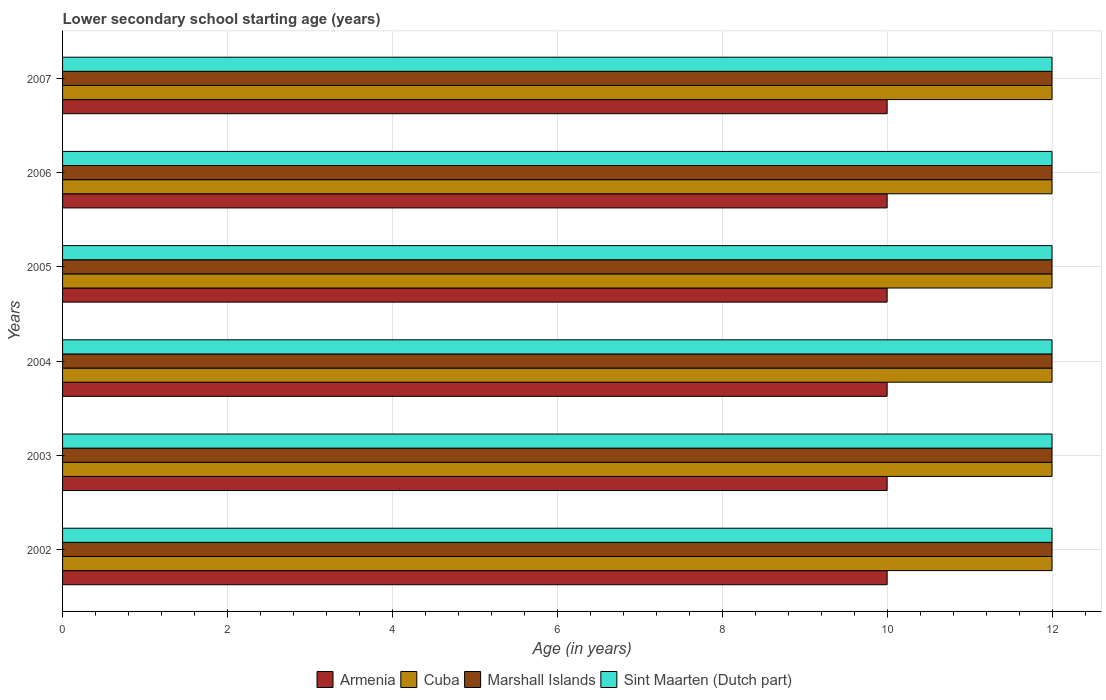How many groups of bars are there?
Give a very brief answer. 6. Are the number of bars on each tick of the Y-axis equal?
Provide a short and direct response. Yes. How many bars are there on the 2nd tick from the bottom?
Offer a very short reply. 4. What is the lower secondary school starting age of children in Armenia in 2002?
Make the answer very short. 10. Across all years, what is the minimum lower secondary school starting age of children in Cuba?
Keep it short and to the point. 12. What is the total lower secondary school starting age of children in Cuba in the graph?
Offer a very short reply. 72. What is the average lower secondary school starting age of children in Sint Maarten (Dutch part) per year?
Provide a succinct answer. 12. In how many years, is the lower secondary school starting age of children in Armenia greater than 4.8 years?
Your answer should be compact. 6. What is the ratio of the lower secondary school starting age of children in Cuba in 2006 to that in 2007?
Ensure brevity in your answer.  1. Is the difference between the lower secondary school starting age of children in Sint Maarten (Dutch part) in 2002 and 2006 greater than the difference between the lower secondary school starting age of children in Armenia in 2002 and 2006?
Provide a short and direct response. No. Is the sum of the lower secondary school starting age of children in Sint Maarten (Dutch part) in 2002 and 2003 greater than the maximum lower secondary school starting age of children in Marshall Islands across all years?
Keep it short and to the point. Yes. What does the 1st bar from the top in 2004 represents?
Provide a succinct answer. Sint Maarten (Dutch part). What does the 2nd bar from the bottom in 2003 represents?
Your answer should be compact. Cuba. Is it the case that in every year, the sum of the lower secondary school starting age of children in Marshall Islands and lower secondary school starting age of children in Armenia is greater than the lower secondary school starting age of children in Cuba?
Ensure brevity in your answer.  Yes. How many bars are there?
Provide a succinct answer. 24. Are all the bars in the graph horizontal?
Your response must be concise. Yes. What is the difference between two consecutive major ticks on the X-axis?
Your answer should be compact. 2. Are the values on the major ticks of X-axis written in scientific E-notation?
Your response must be concise. No. How many legend labels are there?
Offer a very short reply. 4. How are the legend labels stacked?
Keep it short and to the point. Horizontal. What is the title of the graph?
Provide a short and direct response. Lower secondary school starting age (years). What is the label or title of the X-axis?
Offer a very short reply. Age (in years). What is the Age (in years) of Armenia in 2002?
Provide a short and direct response. 10. What is the Age (in years) in Armenia in 2003?
Your response must be concise. 10. What is the Age (in years) of Marshall Islands in 2003?
Provide a succinct answer. 12. What is the Age (in years) in Sint Maarten (Dutch part) in 2003?
Offer a very short reply. 12. What is the Age (in years) in Sint Maarten (Dutch part) in 2004?
Provide a succinct answer. 12. What is the Age (in years) of Armenia in 2005?
Ensure brevity in your answer.  10. What is the Age (in years) of Cuba in 2005?
Ensure brevity in your answer.  12. What is the Age (in years) in Marshall Islands in 2005?
Keep it short and to the point. 12. What is the Age (in years) in Cuba in 2006?
Your answer should be very brief. 12. What is the Age (in years) in Marshall Islands in 2006?
Provide a succinct answer. 12. What is the Age (in years) in Armenia in 2007?
Keep it short and to the point. 10. What is the Age (in years) of Cuba in 2007?
Make the answer very short. 12. What is the Age (in years) in Marshall Islands in 2007?
Make the answer very short. 12. Across all years, what is the maximum Age (in years) in Armenia?
Your answer should be very brief. 10. Across all years, what is the maximum Age (in years) in Cuba?
Provide a succinct answer. 12. Across all years, what is the minimum Age (in years) in Armenia?
Offer a terse response. 10. Across all years, what is the minimum Age (in years) of Marshall Islands?
Provide a succinct answer. 12. What is the total Age (in years) of Armenia in the graph?
Your response must be concise. 60. What is the total Age (in years) in Cuba in the graph?
Keep it short and to the point. 72. What is the difference between the Age (in years) of Armenia in 2002 and that in 2003?
Offer a terse response. 0. What is the difference between the Age (in years) of Cuba in 2002 and that in 2003?
Your answer should be very brief. 0. What is the difference between the Age (in years) in Marshall Islands in 2002 and that in 2003?
Make the answer very short. 0. What is the difference between the Age (in years) of Sint Maarten (Dutch part) in 2002 and that in 2003?
Offer a very short reply. 0. What is the difference between the Age (in years) of Armenia in 2002 and that in 2004?
Ensure brevity in your answer.  0. What is the difference between the Age (in years) in Cuba in 2002 and that in 2004?
Give a very brief answer. 0. What is the difference between the Age (in years) of Marshall Islands in 2002 and that in 2004?
Offer a terse response. 0. What is the difference between the Age (in years) of Sint Maarten (Dutch part) in 2002 and that in 2004?
Your answer should be very brief. 0. What is the difference between the Age (in years) of Armenia in 2002 and that in 2005?
Make the answer very short. 0. What is the difference between the Age (in years) of Cuba in 2002 and that in 2005?
Ensure brevity in your answer.  0. What is the difference between the Age (in years) in Sint Maarten (Dutch part) in 2002 and that in 2005?
Give a very brief answer. 0. What is the difference between the Age (in years) in Cuba in 2002 and that in 2006?
Make the answer very short. 0. What is the difference between the Age (in years) in Marshall Islands in 2002 and that in 2006?
Ensure brevity in your answer.  0. What is the difference between the Age (in years) in Sint Maarten (Dutch part) in 2002 and that in 2006?
Offer a terse response. 0. What is the difference between the Age (in years) in Armenia in 2002 and that in 2007?
Provide a short and direct response. 0. What is the difference between the Age (in years) of Cuba in 2002 and that in 2007?
Your answer should be compact. 0. What is the difference between the Age (in years) in Marshall Islands in 2002 and that in 2007?
Your response must be concise. 0. What is the difference between the Age (in years) of Sint Maarten (Dutch part) in 2002 and that in 2007?
Give a very brief answer. 0. What is the difference between the Age (in years) of Armenia in 2003 and that in 2004?
Your response must be concise. 0. What is the difference between the Age (in years) of Armenia in 2003 and that in 2005?
Ensure brevity in your answer.  0. What is the difference between the Age (in years) of Sint Maarten (Dutch part) in 2003 and that in 2005?
Give a very brief answer. 0. What is the difference between the Age (in years) in Armenia in 2003 and that in 2006?
Make the answer very short. 0. What is the difference between the Age (in years) in Marshall Islands in 2003 and that in 2007?
Your answer should be compact. 0. What is the difference between the Age (in years) of Marshall Islands in 2004 and that in 2005?
Give a very brief answer. 0. What is the difference between the Age (in years) of Armenia in 2004 and that in 2007?
Offer a terse response. 0. What is the difference between the Age (in years) of Marshall Islands in 2004 and that in 2007?
Your response must be concise. 0. What is the difference between the Age (in years) of Sint Maarten (Dutch part) in 2004 and that in 2007?
Your answer should be compact. 0. What is the difference between the Age (in years) of Cuba in 2005 and that in 2006?
Offer a very short reply. 0. What is the difference between the Age (in years) of Marshall Islands in 2005 and that in 2006?
Offer a terse response. 0. What is the difference between the Age (in years) in Cuba in 2005 and that in 2007?
Offer a terse response. 0. What is the difference between the Age (in years) in Armenia in 2006 and that in 2007?
Your answer should be compact. 0. What is the difference between the Age (in years) in Marshall Islands in 2006 and that in 2007?
Provide a short and direct response. 0. What is the difference between the Age (in years) in Cuba in 2002 and the Age (in years) in Sint Maarten (Dutch part) in 2004?
Give a very brief answer. 0. What is the difference between the Age (in years) of Armenia in 2002 and the Age (in years) of Marshall Islands in 2005?
Your response must be concise. -2. What is the difference between the Age (in years) of Armenia in 2002 and the Age (in years) of Sint Maarten (Dutch part) in 2005?
Give a very brief answer. -2. What is the difference between the Age (in years) of Cuba in 2002 and the Age (in years) of Sint Maarten (Dutch part) in 2005?
Your answer should be very brief. 0. What is the difference between the Age (in years) in Armenia in 2002 and the Age (in years) in Marshall Islands in 2006?
Keep it short and to the point. -2. What is the difference between the Age (in years) in Armenia in 2002 and the Age (in years) in Sint Maarten (Dutch part) in 2006?
Keep it short and to the point. -2. What is the difference between the Age (in years) in Cuba in 2002 and the Age (in years) in Marshall Islands in 2006?
Offer a terse response. 0. What is the difference between the Age (in years) in Cuba in 2002 and the Age (in years) in Sint Maarten (Dutch part) in 2006?
Keep it short and to the point. 0. What is the difference between the Age (in years) in Armenia in 2002 and the Age (in years) in Sint Maarten (Dutch part) in 2007?
Provide a succinct answer. -2. What is the difference between the Age (in years) of Cuba in 2002 and the Age (in years) of Sint Maarten (Dutch part) in 2007?
Provide a short and direct response. 0. What is the difference between the Age (in years) of Armenia in 2003 and the Age (in years) of Cuba in 2004?
Provide a short and direct response. -2. What is the difference between the Age (in years) in Cuba in 2003 and the Age (in years) in Marshall Islands in 2004?
Provide a short and direct response. 0. What is the difference between the Age (in years) in Cuba in 2003 and the Age (in years) in Sint Maarten (Dutch part) in 2004?
Your answer should be very brief. 0. What is the difference between the Age (in years) of Armenia in 2003 and the Age (in years) of Marshall Islands in 2005?
Offer a terse response. -2. What is the difference between the Age (in years) in Armenia in 2003 and the Age (in years) in Sint Maarten (Dutch part) in 2005?
Provide a short and direct response. -2. What is the difference between the Age (in years) of Cuba in 2003 and the Age (in years) of Sint Maarten (Dutch part) in 2005?
Ensure brevity in your answer.  0. What is the difference between the Age (in years) in Armenia in 2003 and the Age (in years) in Cuba in 2006?
Keep it short and to the point. -2. What is the difference between the Age (in years) of Armenia in 2003 and the Age (in years) of Marshall Islands in 2006?
Provide a short and direct response. -2. What is the difference between the Age (in years) of Armenia in 2003 and the Age (in years) of Sint Maarten (Dutch part) in 2006?
Your response must be concise. -2. What is the difference between the Age (in years) in Cuba in 2003 and the Age (in years) in Marshall Islands in 2007?
Your answer should be compact. 0. What is the difference between the Age (in years) in Marshall Islands in 2003 and the Age (in years) in Sint Maarten (Dutch part) in 2007?
Give a very brief answer. 0. What is the difference between the Age (in years) of Armenia in 2004 and the Age (in years) of Sint Maarten (Dutch part) in 2005?
Make the answer very short. -2. What is the difference between the Age (in years) in Cuba in 2004 and the Age (in years) in Marshall Islands in 2005?
Provide a succinct answer. 0. What is the difference between the Age (in years) of Cuba in 2004 and the Age (in years) of Marshall Islands in 2006?
Provide a short and direct response. 0. What is the difference between the Age (in years) in Armenia in 2004 and the Age (in years) in Marshall Islands in 2007?
Provide a short and direct response. -2. What is the difference between the Age (in years) of Armenia in 2004 and the Age (in years) of Sint Maarten (Dutch part) in 2007?
Make the answer very short. -2. What is the difference between the Age (in years) of Marshall Islands in 2004 and the Age (in years) of Sint Maarten (Dutch part) in 2007?
Your answer should be very brief. 0. What is the difference between the Age (in years) in Armenia in 2005 and the Age (in years) in Sint Maarten (Dutch part) in 2006?
Your answer should be compact. -2. What is the difference between the Age (in years) of Cuba in 2005 and the Age (in years) of Sint Maarten (Dutch part) in 2006?
Provide a succinct answer. 0. What is the difference between the Age (in years) of Marshall Islands in 2005 and the Age (in years) of Sint Maarten (Dutch part) in 2006?
Provide a succinct answer. 0. What is the difference between the Age (in years) in Armenia in 2005 and the Age (in years) in Cuba in 2007?
Give a very brief answer. -2. What is the difference between the Age (in years) of Armenia in 2005 and the Age (in years) of Marshall Islands in 2007?
Your response must be concise. -2. What is the difference between the Age (in years) in Armenia in 2005 and the Age (in years) in Sint Maarten (Dutch part) in 2007?
Provide a succinct answer. -2. What is the difference between the Age (in years) in Cuba in 2005 and the Age (in years) in Marshall Islands in 2007?
Provide a short and direct response. 0. What is the difference between the Age (in years) of Cuba in 2005 and the Age (in years) of Sint Maarten (Dutch part) in 2007?
Keep it short and to the point. 0. What is the difference between the Age (in years) in Marshall Islands in 2005 and the Age (in years) in Sint Maarten (Dutch part) in 2007?
Your answer should be compact. 0. What is the difference between the Age (in years) of Armenia in 2006 and the Age (in years) of Cuba in 2007?
Your response must be concise. -2. What is the difference between the Age (in years) of Armenia in 2006 and the Age (in years) of Marshall Islands in 2007?
Give a very brief answer. -2. What is the average Age (in years) of Cuba per year?
Your response must be concise. 12. What is the average Age (in years) of Sint Maarten (Dutch part) per year?
Offer a terse response. 12. In the year 2002, what is the difference between the Age (in years) of Marshall Islands and Age (in years) of Sint Maarten (Dutch part)?
Your response must be concise. 0. In the year 2003, what is the difference between the Age (in years) in Armenia and Age (in years) in Cuba?
Ensure brevity in your answer.  -2. In the year 2003, what is the difference between the Age (in years) of Armenia and Age (in years) of Marshall Islands?
Your answer should be very brief. -2. In the year 2003, what is the difference between the Age (in years) in Marshall Islands and Age (in years) in Sint Maarten (Dutch part)?
Keep it short and to the point. 0. In the year 2004, what is the difference between the Age (in years) in Armenia and Age (in years) in Cuba?
Your response must be concise. -2. In the year 2004, what is the difference between the Age (in years) in Armenia and Age (in years) in Marshall Islands?
Your response must be concise. -2. In the year 2004, what is the difference between the Age (in years) of Armenia and Age (in years) of Sint Maarten (Dutch part)?
Make the answer very short. -2. In the year 2004, what is the difference between the Age (in years) of Cuba and Age (in years) of Marshall Islands?
Ensure brevity in your answer.  0. In the year 2004, what is the difference between the Age (in years) in Cuba and Age (in years) in Sint Maarten (Dutch part)?
Your answer should be very brief. 0. In the year 2005, what is the difference between the Age (in years) in Armenia and Age (in years) in Cuba?
Offer a very short reply. -2. In the year 2005, what is the difference between the Age (in years) in Cuba and Age (in years) in Sint Maarten (Dutch part)?
Provide a succinct answer. 0. In the year 2005, what is the difference between the Age (in years) in Marshall Islands and Age (in years) in Sint Maarten (Dutch part)?
Provide a succinct answer. 0. In the year 2006, what is the difference between the Age (in years) in Armenia and Age (in years) in Cuba?
Ensure brevity in your answer.  -2. In the year 2006, what is the difference between the Age (in years) of Armenia and Age (in years) of Sint Maarten (Dutch part)?
Make the answer very short. -2. In the year 2006, what is the difference between the Age (in years) of Cuba and Age (in years) of Sint Maarten (Dutch part)?
Offer a very short reply. 0. In the year 2007, what is the difference between the Age (in years) of Armenia and Age (in years) of Marshall Islands?
Offer a terse response. -2. In the year 2007, what is the difference between the Age (in years) of Cuba and Age (in years) of Marshall Islands?
Keep it short and to the point. 0. In the year 2007, what is the difference between the Age (in years) in Cuba and Age (in years) in Sint Maarten (Dutch part)?
Ensure brevity in your answer.  0. What is the ratio of the Age (in years) in Armenia in 2002 to that in 2003?
Your answer should be very brief. 1. What is the ratio of the Age (in years) in Cuba in 2002 to that in 2003?
Keep it short and to the point. 1. What is the ratio of the Age (in years) of Sint Maarten (Dutch part) in 2002 to that in 2003?
Offer a terse response. 1. What is the ratio of the Age (in years) of Cuba in 2002 to that in 2004?
Your answer should be very brief. 1. What is the ratio of the Age (in years) in Sint Maarten (Dutch part) in 2002 to that in 2004?
Keep it short and to the point. 1. What is the ratio of the Age (in years) in Armenia in 2002 to that in 2007?
Keep it short and to the point. 1. What is the ratio of the Age (in years) in Cuba in 2002 to that in 2007?
Offer a very short reply. 1. What is the ratio of the Age (in years) of Marshall Islands in 2002 to that in 2007?
Your answer should be compact. 1. What is the ratio of the Age (in years) of Sint Maarten (Dutch part) in 2002 to that in 2007?
Your response must be concise. 1. What is the ratio of the Age (in years) of Armenia in 2003 to that in 2004?
Offer a very short reply. 1. What is the ratio of the Age (in years) in Sint Maarten (Dutch part) in 2003 to that in 2005?
Your answer should be compact. 1. What is the ratio of the Age (in years) in Armenia in 2003 to that in 2006?
Make the answer very short. 1. What is the ratio of the Age (in years) of Cuba in 2003 to that in 2006?
Your answer should be very brief. 1. What is the ratio of the Age (in years) of Marshall Islands in 2003 to that in 2006?
Your response must be concise. 1. What is the ratio of the Age (in years) in Sint Maarten (Dutch part) in 2003 to that in 2006?
Your answer should be very brief. 1. What is the ratio of the Age (in years) of Sint Maarten (Dutch part) in 2003 to that in 2007?
Provide a succinct answer. 1. What is the ratio of the Age (in years) in Marshall Islands in 2004 to that in 2005?
Provide a succinct answer. 1. What is the ratio of the Age (in years) in Sint Maarten (Dutch part) in 2004 to that in 2005?
Your response must be concise. 1. What is the ratio of the Age (in years) in Sint Maarten (Dutch part) in 2004 to that in 2006?
Provide a succinct answer. 1. What is the ratio of the Age (in years) of Cuba in 2004 to that in 2007?
Keep it short and to the point. 1. What is the ratio of the Age (in years) of Armenia in 2005 to that in 2006?
Make the answer very short. 1. What is the ratio of the Age (in years) in Cuba in 2005 to that in 2006?
Offer a very short reply. 1. What is the ratio of the Age (in years) of Marshall Islands in 2005 to that in 2006?
Offer a terse response. 1. What is the ratio of the Age (in years) in Sint Maarten (Dutch part) in 2005 to that in 2006?
Ensure brevity in your answer.  1. What is the ratio of the Age (in years) in Armenia in 2005 to that in 2007?
Offer a terse response. 1. What is the ratio of the Age (in years) in Cuba in 2005 to that in 2007?
Provide a succinct answer. 1. What is the ratio of the Age (in years) in Marshall Islands in 2005 to that in 2007?
Keep it short and to the point. 1. What is the ratio of the Age (in years) in Sint Maarten (Dutch part) in 2005 to that in 2007?
Provide a succinct answer. 1. What is the ratio of the Age (in years) in Sint Maarten (Dutch part) in 2006 to that in 2007?
Offer a terse response. 1. What is the difference between the highest and the second highest Age (in years) of Armenia?
Ensure brevity in your answer.  0. What is the difference between the highest and the second highest Age (in years) in Sint Maarten (Dutch part)?
Your answer should be very brief. 0. What is the difference between the highest and the lowest Age (in years) of Cuba?
Provide a short and direct response. 0. 